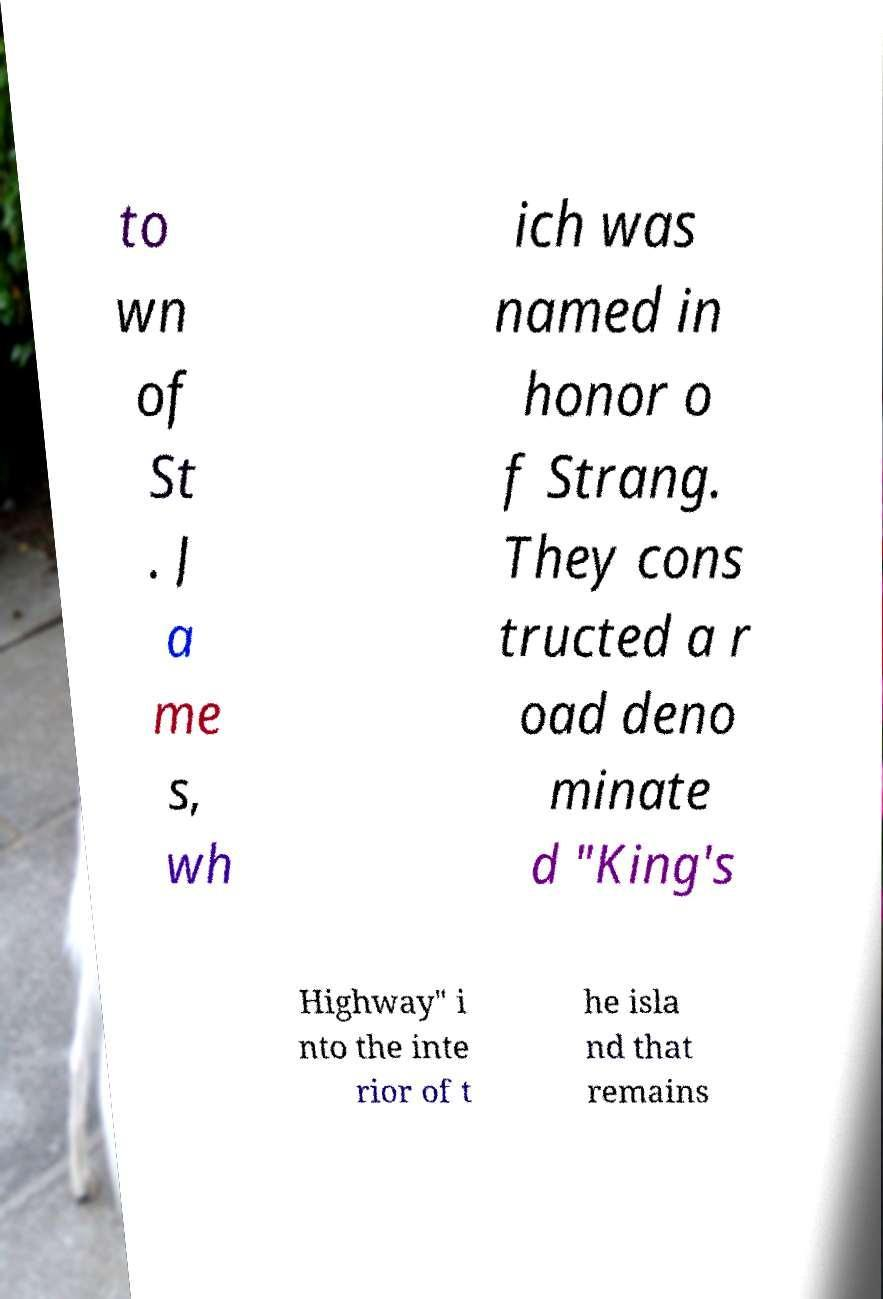I need the written content from this picture converted into text. Can you do that? to wn of St . J a me s, wh ich was named in honor o f Strang. They cons tructed a r oad deno minate d "King's Highway" i nto the inte rior of t he isla nd that remains 